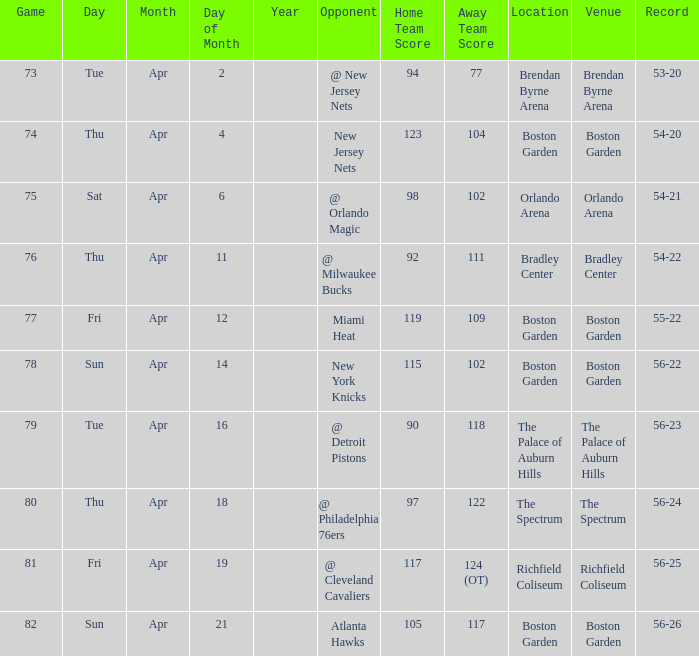Which Opponent has a Score of 92-111? @ Milwaukee Bucks. 